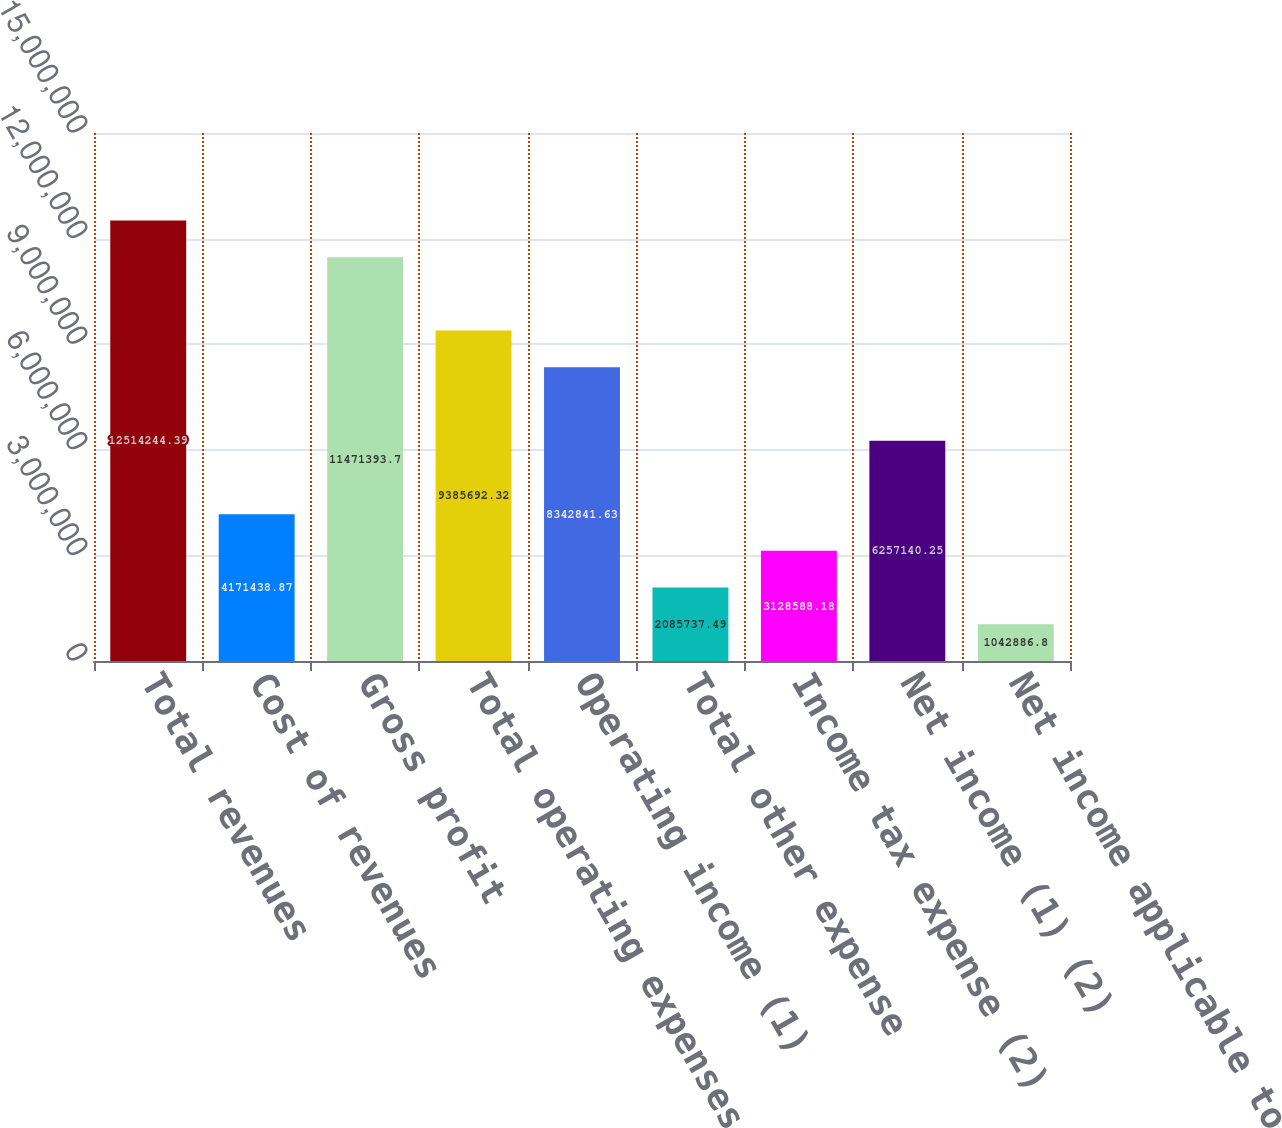<chart> <loc_0><loc_0><loc_500><loc_500><bar_chart><fcel>Total revenues<fcel>Cost of revenues<fcel>Gross profit<fcel>Total operating expenses (1)<fcel>Operating income (1)<fcel>Total other expense<fcel>Income tax expense (2)<fcel>Net income (1) (2)<fcel>Net income applicable to<nl><fcel>1.25142e+07<fcel>4.17144e+06<fcel>1.14714e+07<fcel>9.38569e+06<fcel>8.34284e+06<fcel>2.08574e+06<fcel>3.12859e+06<fcel>6.25714e+06<fcel>1.04289e+06<nl></chart> 